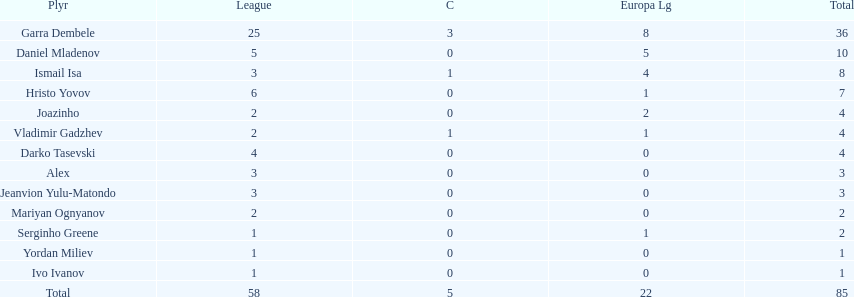How many of the players did not score any goals in the cup? 10. 